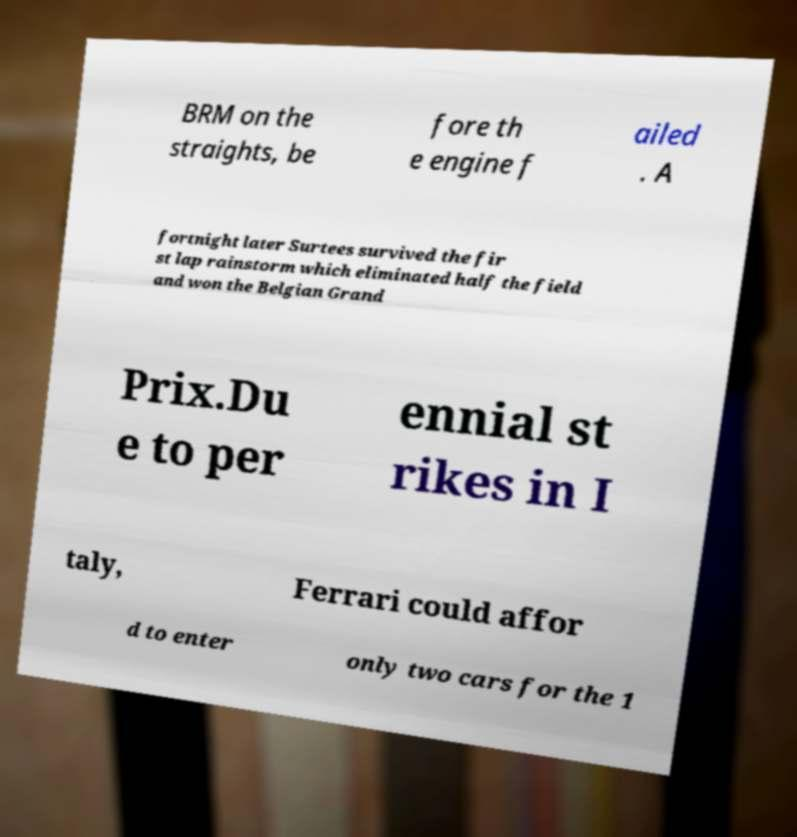Could you extract and type out the text from this image? BRM on the straights, be fore th e engine f ailed . A fortnight later Surtees survived the fir st lap rainstorm which eliminated half the field and won the Belgian Grand Prix.Du e to per ennial st rikes in I taly, Ferrari could affor d to enter only two cars for the 1 